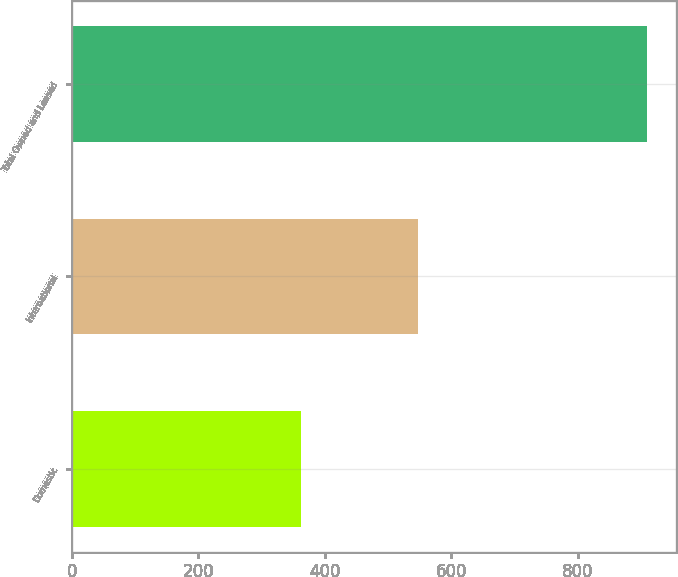<chart> <loc_0><loc_0><loc_500><loc_500><bar_chart><fcel>Domestic<fcel>International<fcel>Total Owned and Leased<nl><fcel>363<fcel>547<fcel>910<nl></chart> 